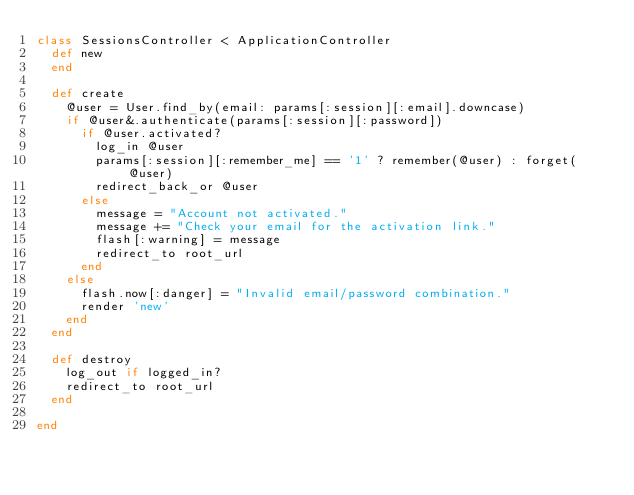Convert code to text. <code><loc_0><loc_0><loc_500><loc_500><_Ruby_>class SessionsController < ApplicationController
  def new
  end

  def create
    @user = User.find_by(email: params[:session][:email].downcase)
    if @user&.authenticate(params[:session][:password])
      if @user.activated?
        log_in @user
        params[:session][:remember_me] == '1' ? remember(@user) : forget(@user)
        redirect_back_or @user
      else
        message = "Account not activated."
        message += "Check your email for the activation link."
        flash[:warning] = message
        redirect_to root_url
      end
    else
      flash.now[:danger] = "Invalid email/password combination." 
      render 'new'
    end
  end

  def destroy
    log_out if logged_in?
    redirect_to root_url
  end

end
</code> 